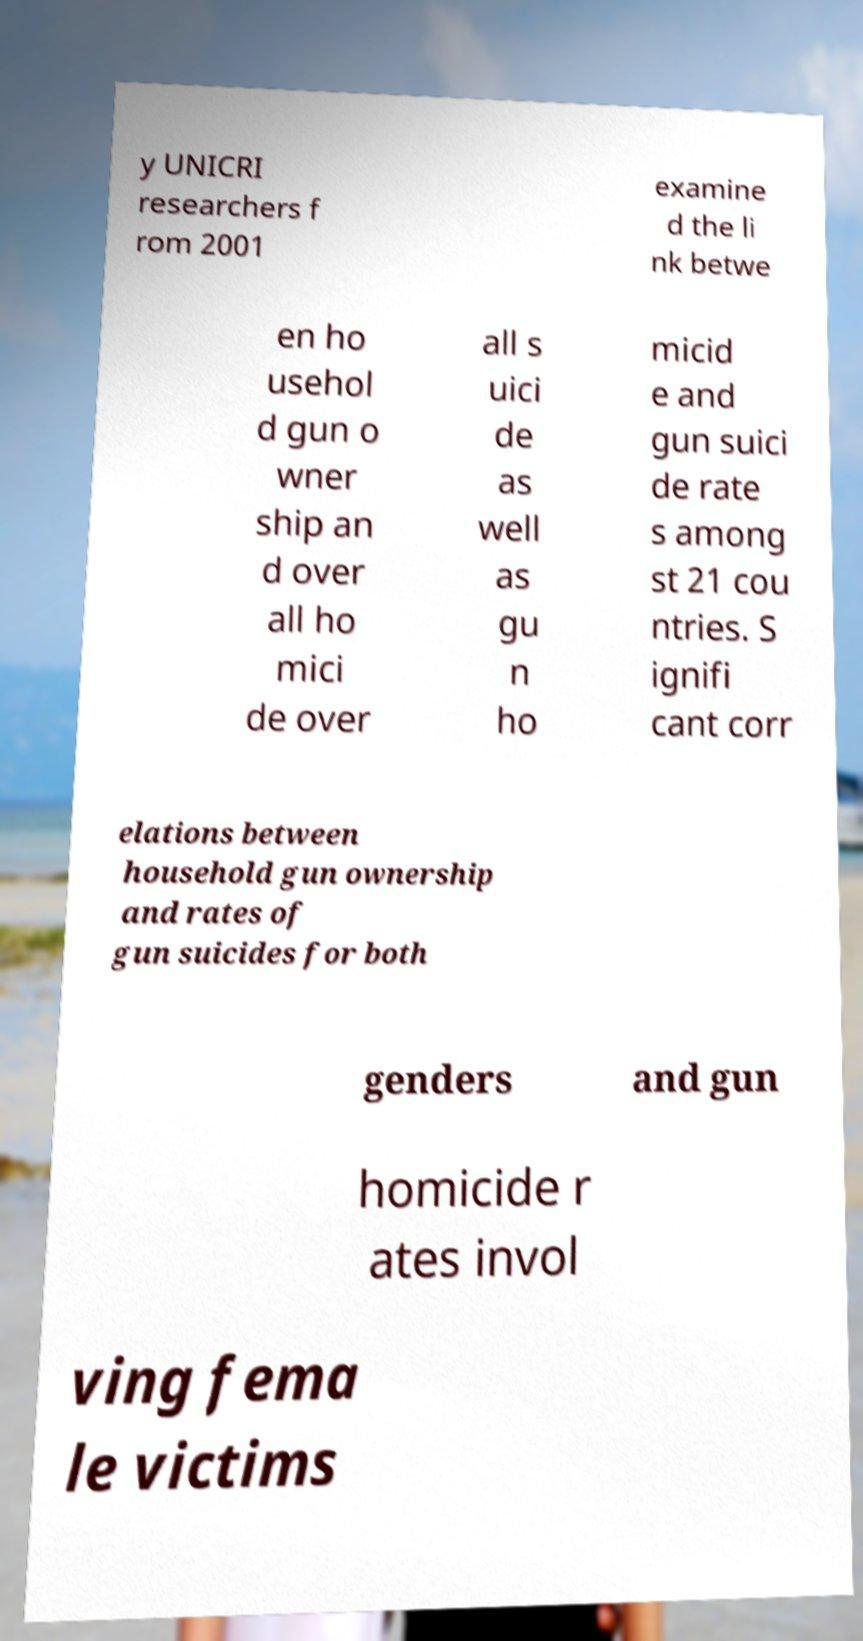Please identify and transcribe the text found in this image. y UNICRI researchers f rom 2001 examine d the li nk betwe en ho usehol d gun o wner ship an d over all ho mici de over all s uici de as well as gu n ho micid e and gun suici de rate s among st 21 cou ntries. S ignifi cant corr elations between household gun ownership and rates of gun suicides for both genders and gun homicide r ates invol ving fema le victims 